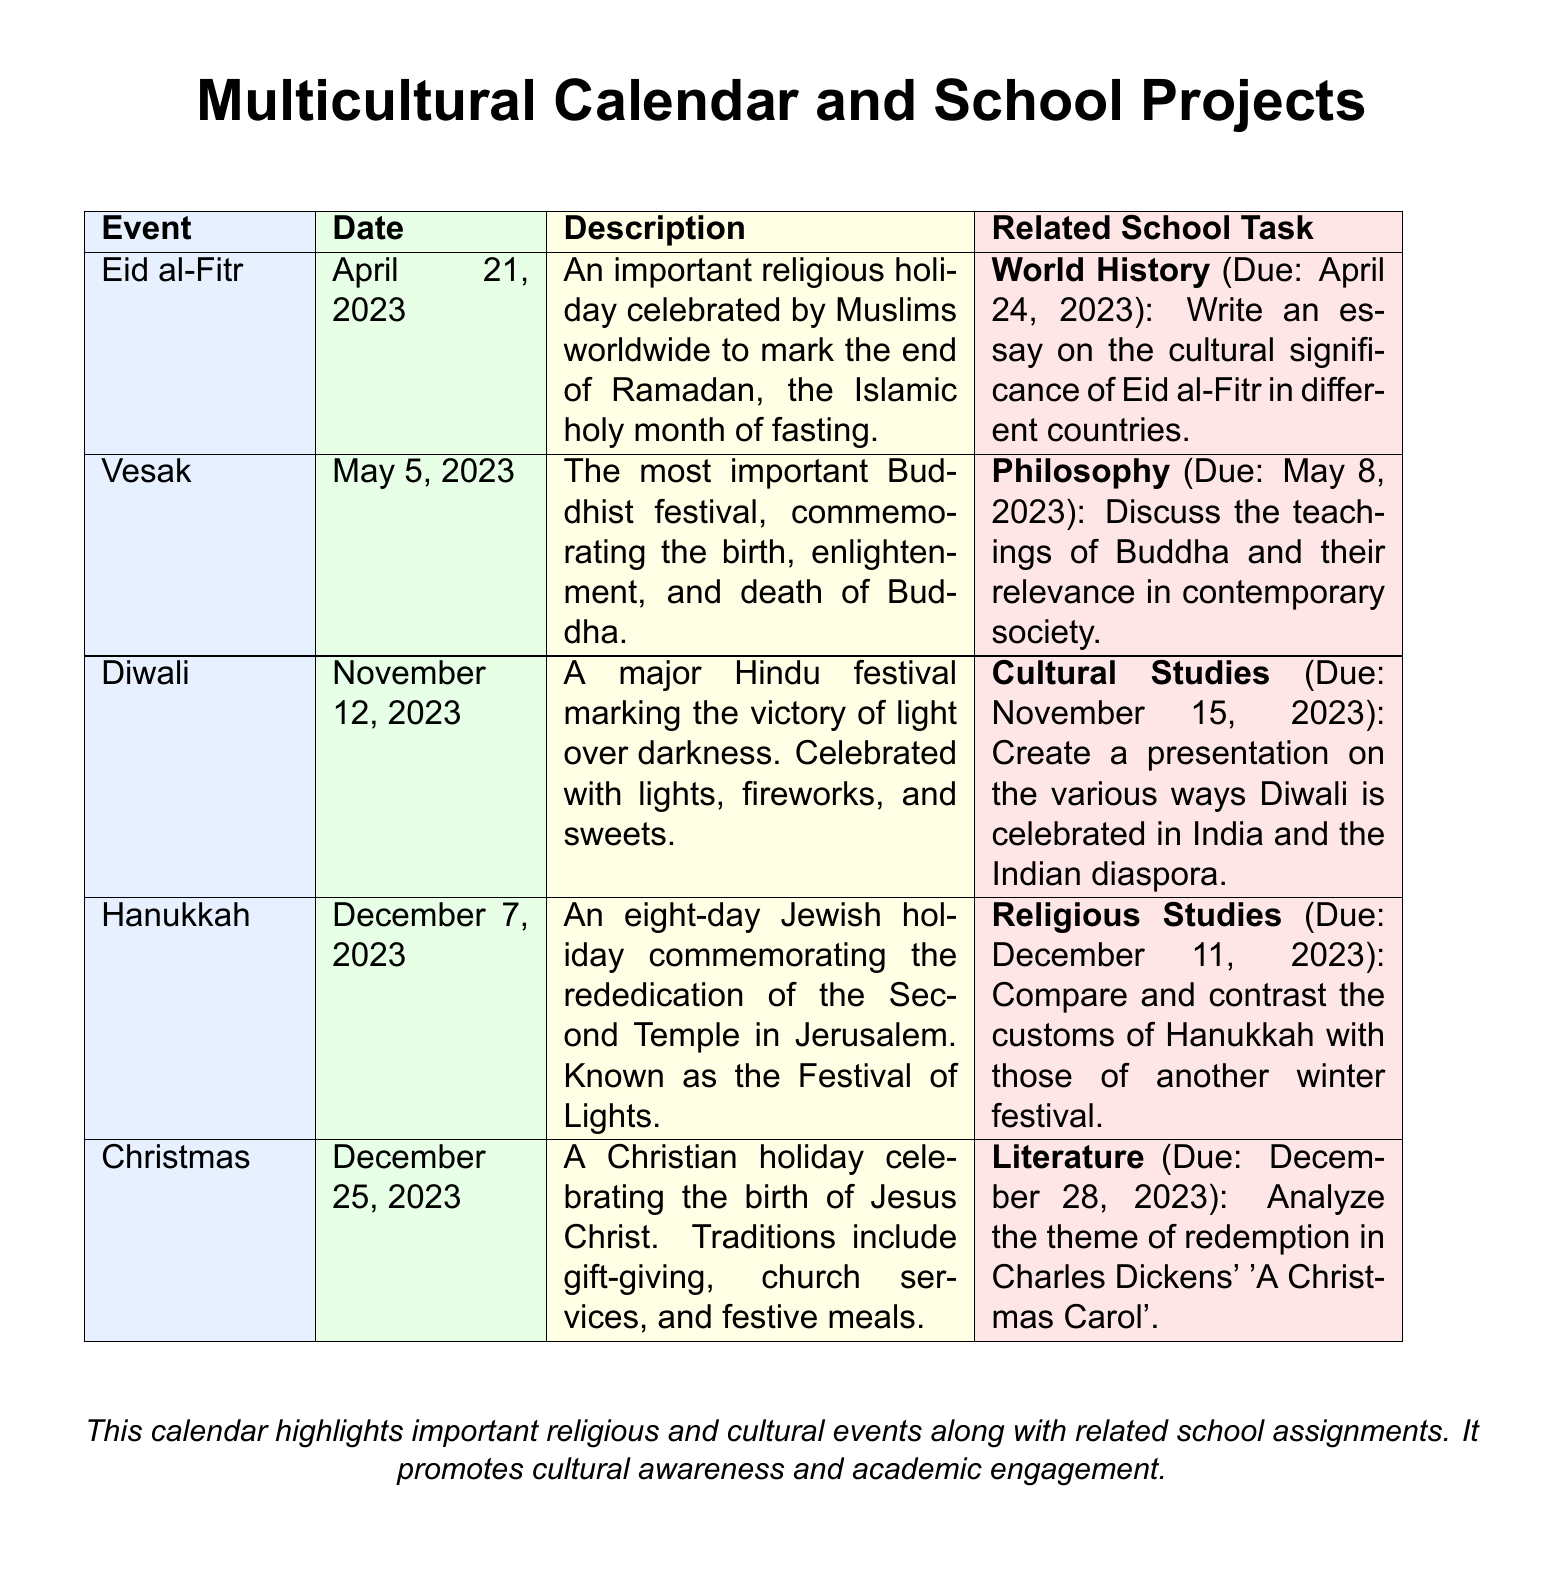What is the date of Eid al-Fitr? The date listed for Eid al-Fitr in the document is April 21, 2023.
Answer: April 21, 2023 What is the main significance of Diwali? Diwali marks the victory of light over darkness, as mentioned in the description.
Answer: Victory of light over darkness Which religious holiday is celebrated on December 7, 2023? The document specifies that Hanukkah is celebrated on December 7, 2023.
Answer: Hanukkah What school task is associated with Vesak? The document states the school task for Vesak relates to discussing the teachings of Buddha.
Answer: Discuss the teachings of Buddha How many days does Hanukkah last? Hanukkah is described as an eight-day holiday in the document.
Answer: Eight days What is the due date for the Cultural Studies task related to Diwali? The due date for the Cultural Studies task is noted as November 15, 2023.
Answer: November 15, 2023 Which holiday is associated with gift-giving traditions? The document indicates that Christmas is associated with gift-giving traditions.
Answer: Christmas What is the project topic for the World History task? The topic for the World History task is on the cultural significance of Eid al-Fitr.
Answer: Cultural significance of Eid al-Fitr 